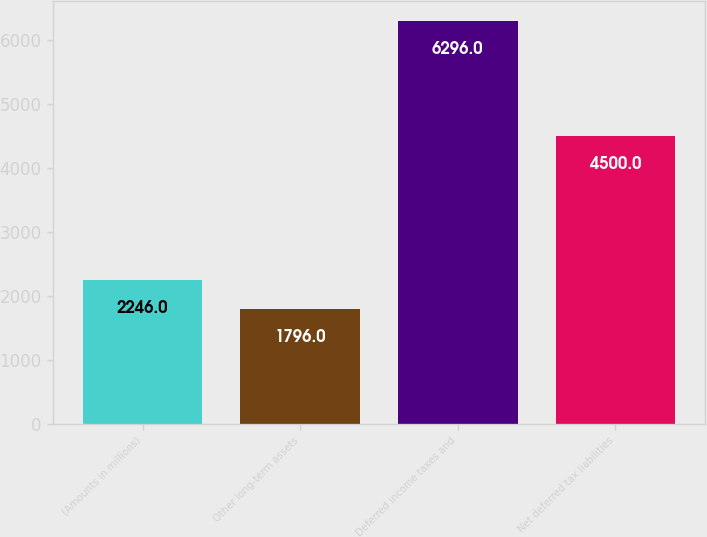Convert chart to OTSL. <chart><loc_0><loc_0><loc_500><loc_500><bar_chart><fcel>(Amounts in millions)<fcel>Other long-term assets<fcel>Deferred income taxes and<fcel>Net deferred tax liabilities<nl><fcel>2246<fcel>1796<fcel>6296<fcel>4500<nl></chart> 